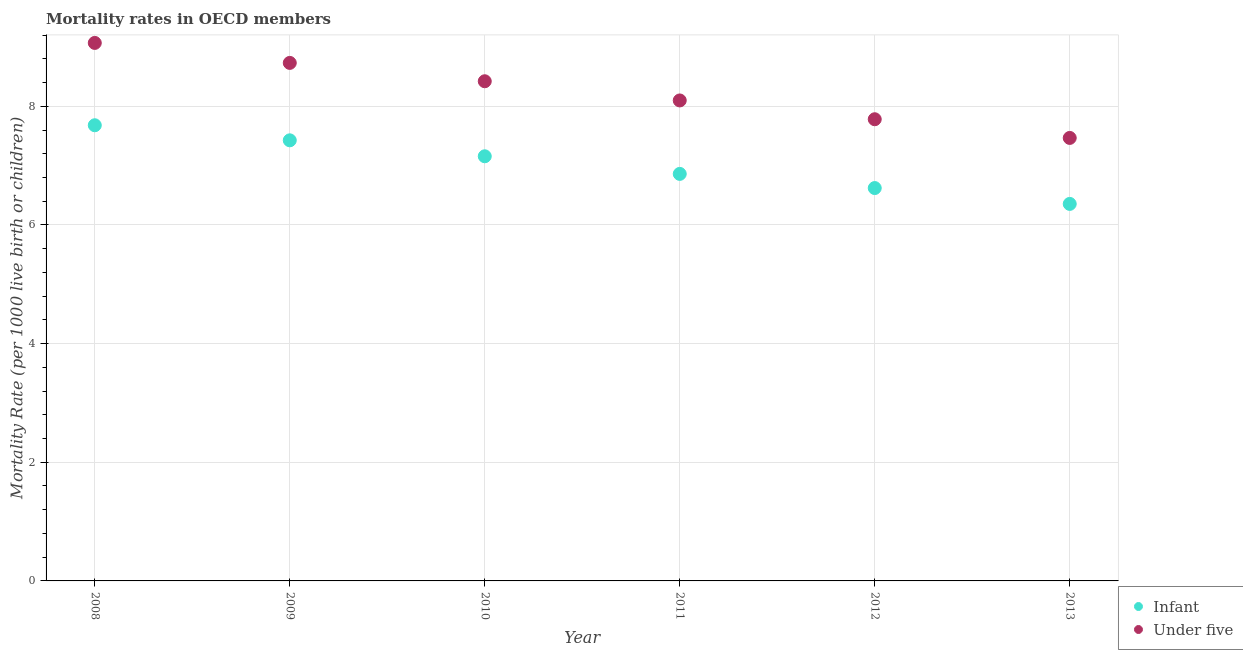How many different coloured dotlines are there?
Your response must be concise. 2. Is the number of dotlines equal to the number of legend labels?
Ensure brevity in your answer.  Yes. What is the infant mortality rate in 2009?
Your response must be concise. 7.43. Across all years, what is the maximum infant mortality rate?
Offer a terse response. 7.68. Across all years, what is the minimum infant mortality rate?
Keep it short and to the point. 6.35. What is the total under-5 mortality rate in the graph?
Give a very brief answer. 49.57. What is the difference between the under-5 mortality rate in 2010 and that in 2013?
Your response must be concise. 0.96. What is the difference between the under-5 mortality rate in 2011 and the infant mortality rate in 2012?
Make the answer very short. 1.48. What is the average under-5 mortality rate per year?
Ensure brevity in your answer.  8.26. In the year 2013, what is the difference between the under-5 mortality rate and infant mortality rate?
Make the answer very short. 1.11. In how many years, is the infant mortality rate greater than 3.6?
Give a very brief answer. 6. What is the ratio of the under-5 mortality rate in 2008 to that in 2011?
Your response must be concise. 1.12. Is the under-5 mortality rate in 2008 less than that in 2011?
Provide a short and direct response. No. What is the difference between the highest and the second highest under-5 mortality rate?
Your response must be concise. 0.34. What is the difference between the highest and the lowest infant mortality rate?
Make the answer very short. 1.33. In how many years, is the infant mortality rate greater than the average infant mortality rate taken over all years?
Your response must be concise. 3. Is the sum of the infant mortality rate in 2008 and 2009 greater than the maximum under-5 mortality rate across all years?
Provide a short and direct response. Yes. Is the infant mortality rate strictly greater than the under-5 mortality rate over the years?
Your answer should be compact. No. How many dotlines are there?
Make the answer very short. 2. How many years are there in the graph?
Ensure brevity in your answer.  6. What is the difference between two consecutive major ticks on the Y-axis?
Provide a succinct answer. 2. Does the graph contain grids?
Offer a very short reply. Yes. Where does the legend appear in the graph?
Give a very brief answer. Bottom right. How many legend labels are there?
Your answer should be very brief. 2. How are the legend labels stacked?
Provide a succinct answer. Vertical. What is the title of the graph?
Give a very brief answer. Mortality rates in OECD members. What is the label or title of the Y-axis?
Your answer should be very brief. Mortality Rate (per 1000 live birth or children). What is the Mortality Rate (per 1000 live birth or children) of Infant in 2008?
Offer a terse response. 7.68. What is the Mortality Rate (per 1000 live birth or children) in Under five in 2008?
Keep it short and to the point. 9.07. What is the Mortality Rate (per 1000 live birth or children) in Infant in 2009?
Your response must be concise. 7.43. What is the Mortality Rate (per 1000 live birth or children) of Under five in 2009?
Give a very brief answer. 8.73. What is the Mortality Rate (per 1000 live birth or children) in Infant in 2010?
Ensure brevity in your answer.  7.16. What is the Mortality Rate (per 1000 live birth or children) in Under five in 2010?
Your answer should be very brief. 8.42. What is the Mortality Rate (per 1000 live birth or children) in Infant in 2011?
Your answer should be very brief. 6.86. What is the Mortality Rate (per 1000 live birth or children) in Under five in 2011?
Your answer should be compact. 8.1. What is the Mortality Rate (per 1000 live birth or children) of Infant in 2012?
Offer a terse response. 6.62. What is the Mortality Rate (per 1000 live birth or children) of Under five in 2012?
Keep it short and to the point. 7.78. What is the Mortality Rate (per 1000 live birth or children) of Infant in 2013?
Give a very brief answer. 6.35. What is the Mortality Rate (per 1000 live birth or children) in Under five in 2013?
Ensure brevity in your answer.  7.47. Across all years, what is the maximum Mortality Rate (per 1000 live birth or children) in Infant?
Provide a short and direct response. 7.68. Across all years, what is the maximum Mortality Rate (per 1000 live birth or children) of Under five?
Provide a succinct answer. 9.07. Across all years, what is the minimum Mortality Rate (per 1000 live birth or children) of Infant?
Your answer should be very brief. 6.35. Across all years, what is the minimum Mortality Rate (per 1000 live birth or children) of Under five?
Offer a terse response. 7.47. What is the total Mortality Rate (per 1000 live birth or children) in Infant in the graph?
Provide a succinct answer. 42.1. What is the total Mortality Rate (per 1000 live birth or children) in Under five in the graph?
Ensure brevity in your answer.  49.57. What is the difference between the Mortality Rate (per 1000 live birth or children) of Infant in 2008 and that in 2009?
Provide a short and direct response. 0.25. What is the difference between the Mortality Rate (per 1000 live birth or children) in Under five in 2008 and that in 2009?
Make the answer very short. 0.34. What is the difference between the Mortality Rate (per 1000 live birth or children) in Infant in 2008 and that in 2010?
Keep it short and to the point. 0.52. What is the difference between the Mortality Rate (per 1000 live birth or children) in Under five in 2008 and that in 2010?
Make the answer very short. 0.65. What is the difference between the Mortality Rate (per 1000 live birth or children) of Infant in 2008 and that in 2011?
Keep it short and to the point. 0.82. What is the difference between the Mortality Rate (per 1000 live birth or children) of Under five in 2008 and that in 2011?
Your answer should be compact. 0.97. What is the difference between the Mortality Rate (per 1000 live birth or children) of Infant in 2008 and that in 2012?
Make the answer very short. 1.06. What is the difference between the Mortality Rate (per 1000 live birth or children) in Under five in 2008 and that in 2012?
Provide a succinct answer. 1.29. What is the difference between the Mortality Rate (per 1000 live birth or children) of Infant in 2008 and that in 2013?
Provide a short and direct response. 1.33. What is the difference between the Mortality Rate (per 1000 live birth or children) in Under five in 2008 and that in 2013?
Your answer should be very brief. 1.6. What is the difference between the Mortality Rate (per 1000 live birth or children) of Infant in 2009 and that in 2010?
Keep it short and to the point. 0.27. What is the difference between the Mortality Rate (per 1000 live birth or children) in Under five in 2009 and that in 2010?
Ensure brevity in your answer.  0.31. What is the difference between the Mortality Rate (per 1000 live birth or children) in Infant in 2009 and that in 2011?
Provide a short and direct response. 0.57. What is the difference between the Mortality Rate (per 1000 live birth or children) of Under five in 2009 and that in 2011?
Your answer should be very brief. 0.63. What is the difference between the Mortality Rate (per 1000 live birth or children) in Infant in 2009 and that in 2012?
Give a very brief answer. 0.8. What is the difference between the Mortality Rate (per 1000 live birth or children) in Under five in 2009 and that in 2012?
Provide a succinct answer. 0.95. What is the difference between the Mortality Rate (per 1000 live birth or children) of Infant in 2009 and that in 2013?
Offer a very short reply. 1.07. What is the difference between the Mortality Rate (per 1000 live birth or children) in Under five in 2009 and that in 2013?
Provide a short and direct response. 1.26. What is the difference between the Mortality Rate (per 1000 live birth or children) in Infant in 2010 and that in 2011?
Your answer should be compact. 0.3. What is the difference between the Mortality Rate (per 1000 live birth or children) in Under five in 2010 and that in 2011?
Offer a terse response. 0.32. What is the difference between the Mortality Rate (per 1000 live birth or children) in Infant in 2010 and that in 2012?
Give a very brief answer. 0.54. What is the difference between the Mortality Rate (per 1000 live birth or children) in Under five in 2010 and that in 2012?
Offer a terse response. 0.64. What is the difference between the Mortality Rate (per 1000 live birth or children) in Infant in 2010 and that in 2013?
Your response must be concise. 0.8. What is the difference between the Mortality Rate (per 1000 live birth or children) in Under five in 2010 and that in 2013?
Ensure brevity in your answer.  0.96. What is the difference between the Mortality Rate (per 1000 live birth or children) of Infant in 2011 and that in 2012?
Give a very brief answer. 0.24. What is the difference between the Mortality Rate (per 1000 live birth or children) of Under five in 2011 and that in 2012?
Make the answer very short. 0.32. What is the difference between the Mortality Rate (per 1000 live birth or children) in Infant in 2011 and that in 2013?
Your answer should be compact. 0.51. What is the difference between the Mortality Rate (per 1000 live birth or children) of Under five in 2011 and that in 2013?
Your answer should be very brief. 0.63. What is the difference between the Mortality Rate (per 1000 live birth or children) of Infant in 2012 and that in 2013?
Offer a terse response. 0.27. What is the difference between the Mortality Rate (per 1000 live birth or children) in Under five in 2012 and that in 2013?
Provide a succinct answer. 0.32. What is the difference between the Mortality Rate (per 1000 live birth or children) in Infant in 2008 and the Mortality Rate (per 1000 live birth or children) in Under five in 2009?
Offer a terse response. -1.05. What is the difference between the Mortality Rate (per 1000 live birth or children) in Infant in 2008 and the Mortality Rate (per 1000 live birth or children) in Under five in 2010?
Offer a very short reply. -0.74. What is the difference between the Mortality Rate (per 1000 live birth or children) in Infant in 2008 and the Mortality Rate (per 1000 live birth or children) in Under five in 2011?
Keep it short and to the point. -0.42. What is the difference between the Mortality Rate (per 1000 live birth or children) of Infant in 2008 and the Mortality Rate (per 1000 live birth or children) of Under five in 2012?
Your answer should be compact. -0.1. What is the difference between the Mortality Rate (per 1000 live birth or children) of Infant in 2008 and the Mortality Rate (per 1000 live birth or children) of Under five in 2013?
Offer a terse response. 0.21. What is the difference between the Mortality Rate (per 1000 live birth or children) of Infant in 2009 and the Mortality Rate (per 1000 live birth or children) of Under five in 2010?
Offer a very short reply. -1. What is the difference between the Mortality Rate (per 1000 live birth or children) in Infant in 2009 and the Mortality Rate (per 1000 live birth or children) in Under five in 2011?
Your response must be concise. -0.67. What is the difference between the Mortality Rate (per 1000 live birth or children) of Infant in 2009 and the Mortality Rate (per 1000 live birth or children) of Under five in 2012?
Your answer should be compact. -0.36. What is the difference between the Mortality Rate (per 1000 live birth or children) in Infant in 2009 and the Mortality Rate (per 1000 live birth or children) in Under five in 2013?
Give a very brief answer. -0.04. What is the difference between the Mortality Rate (per 1000 live birth or children) of Infant in 2010 and the Mortality Rate (per 1000 live birth or children) of Under five in 2011?
Your answer should be very brief. -0.94. What is the difference between the Mortality Rate (per 1000 live birth or children) in Infant in 2010 and the Mortality Rate (per 1000 live birth or children) in Under five in 2012?
Ensure brevity in your answer.  -0.62. What is the difference between the Mortality Rate (per 1000 live birth or children) in Infant in 2010 and the Mortality Rate (per 1000 live birth or children) in Under five in 2013?
Your response must be concise. -0.31. What is the difference between the Mortality Rate (per 1000 live birth or children) in Infant in 2011 and the Mortality Rate (per 1000 live birth or children) in Under five in 2012?
Offer a very short reply. -0.92. What is the difference between the Mortality Rate (per 1000 live birth or children) of Infant in 2011 and the Mortality Rate (per 1000 live birth or children) of Under five in 2013?
Offer a terse response. -0.61. What is the difference between the Mortality Rate (per 1000 live birth or children) in Infant in 2012 and the Mortality Rate (per 1000 live birth or children) in Under five in 2013?
Your answer should be very brief. -0.84. What is the average Mortality Rate (per 1000 live birth or children) in Infant per year?
Make the answer very short. 7.02. What is the average Mortality Rate (per 1000 live birth or children) in Under five per year?
Keep it short and to the point. 8.26. In the year 2008, what is the difference between the Mortality Rate (per 1000 live birth or children) of Infant and Mortality Rate (per 1000 live birth or children) of Under five?
Offer a very short reply. -1.39. In the year 2009, what is the difference between the Mortality Rate (per 1000 live birth or children) in Infant and Mortality Rate (per 1000 live birth or children) in Under five?
Ensure brevity in your answer.  -1.3. In the year 2010, what is the difference between the Mortality Rate (per 1000 live birth or children) in Infant and Mortality Rate (per 1000 live birth or children) in Under five?
Offer a very short reply. -1.26. In the year 2011, what is the difference between the Mortality Rate (per 1000 live birth or children) in Infant and Mortality Rate (per 1000 live birth or children) in Under five?
Offer a terse response. -1.24. In the year 2012, what is the difference between the Mortality Rate (per 1000 live birth or children) in Infant and Mortality Rate (per 1000 live birth or children) in Under five?
Give a very brief answer. -1.16. In the year 2013, what is the difference between the Mortality Rate (per 1000 live birth or children) of Infant and Mortality Rate (per 1000 live birth or children) of Under five?
Your answer should be very brief. -1.11. What is the ratio of the Mortality Rate (per 1000 live birth or children) of Infant in 2008 to that in 2009?
Provide a short and direct response. 1.03. What is the ratio of the Mortality Rate (per 1000 live birth or children) of Under five in 2008 to that in 2009?
Provide a short and direct response. 1.04. What is the ratio of the Mortality Rate (per 1000 live birth or children) in Infant in 2008 to that in 2010?
Your answer should be compact. 1.07. What is the ratio of the Mortality Rate (per 1000 live birth or children) in Under five in 2008 to that in 2010?
Provide a short and direct response. 1.08. What is the ratio of the Mortality Rate (per 1000 live birth or children) of Infant in 2008 to that in 2011?
Give a very brief answer. 1.12. What is the ratio of the Mortality Rate (per 1000 live birth or children) in Under five in 2008 to that in 2011?
Offer a terse response. 1.12. What is the ratio of the Mortality Rate (per 1000 live birth or children) in Infant in 2008 to that in 2012?
Give a very brief answer. 1.16. What is the ratio of the Mortality Rate (per 1000 live birth or children) in Under five in 2008 to that in 2012?
Ensure brevity in your answer.  1.17. What is the ratio of the Mortality Rate (per 1000 live birth or children) of Infant in 2008 to that in 2013?
Provide a succinct answer. 1.21. What is the ratio of the Mortality Rate (per 1000 live birth or children) in Under five in 2008 to that in 2013?
Offer a terse response. 1.21. What is the ratio of the Mortality Rate (per 1000 live birth or children) of Infant in 2009 to that in 2010?
Provide a succinct answer. 1.04. What is the ratio of the Mortality Rate (per 1000 live birth or children) in Under five in 2009 to that in 2010?
Provide a short and direct response. 1.04. What is the ratio of the Mortality Rate (per 1000 live birth or children) of Infant in 2009 to that in 2011?
Ensure brevity in your answer.  1.08. What is the ratio of the Mortality Rate (per 1000 live birth or children) in Under five in 2009 to that in 2011?
Offer a terse response. 1.08. What is the ratio of the Mortality Rate (per 1000 live birth or children) of Infant in 2009 to that in 2012?
Make the answer very short. 1.12. What is the ratio of the Mortality Rate (per 1000 live birth or children) of Under five in 2009 to that in 2012?
Your answer should be very brief. 1.12. What is the ratio of the Mortality Rate (per 1000 live birth or children) in Infant in 2009 to that in 2013?
Provide a succinct answer. 1.17. What is the ratio of the Mortality Rate (per 1000 live birth or children) in Under five in 2009 to that in 2013?
Offer a very short reply. 1.17. What is the ratio of the Mortality Rate (per 1000 live birth or children) in Infant in 2010 to that in 2011?
Your response must be concise. 1.04. What is the ratio of the Mortality Rate (per 1000 live birth or children) in Under five in 2010 to that in 2011?
Keep it short and to the point. 1.04. What is the ratio of the Mortality Rate (per 1000 live birth or children) of Infant in 2010 to that in 2012?
Provide a short and direct response. 1.08. What is the ratio of the Mortality Rate (per 1000 live birth or children) of Under five in 2010 to that in 2012?
Provide a short and direct response. 1.08. What is the ratio of the Mortality Rate (per 1000 live birth or children) of Infant in 2010 to that in 2013?
Your answer should be very brief. 1.13. What is the ratio of the Mortality Rate (per 1000 live birth or children) of Under five in 2010 to that in 2013?
Provide a short and direct response. 1.13. What is the ratio of the Mortality Rate (per 1000 live birth or children) in Infant in 2011 to that in 2012?
Your answer should be very brief. 1.04. What is the ratio of the Mortality Rate (per 1000 live birth or children) of Under five in 2011 to that in 2012?
Offer a terse response. 1.04. What is the ratio of the Mortality Rate (per 1000 live birth or children) in Infant in 2011 to that in 2013?
Keep it short and to the point. 1.08. What is the ratio of the Mortality Rate (per 1000 live birth or children) of Under five in 2011 to that in 2013?
Provide a short and direct response. 1.08. What is the ratio of the Mortality Rate (per 1000 live birth or children) in Infant in 2012 to that in 2013?
Make the answer very short. 1.04. What is the ratio of the Mortality Rate (per 1000 live birth or children) of Under five in 2012 to that in 2013?
Your answer should be very brief. 1.04. What is the difference between the highest and the second highest Mortality Rate (per 1000 live birth or children) of Infant?
Your answer should be very brief. 0.25. What is the difference between the highest and the second highest Mortality Rate (per 1000 live birth or children) in Under five?
Provide a short and direct response. 0.34. What is the difference between the highest and the lowest Mortality Rate (per 1000 live birth or children) in Infant?
Your response must be concise. 1.33. What is the difference between the highest and the lowest Mortality Rate (per 1000 live birth or children) in Under five?
Keep it short and to the point. 1.6. 